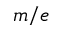Convert formula to latex. <formula><loc_0><loc_0><loc_500><loc_500>m / e</formula> 